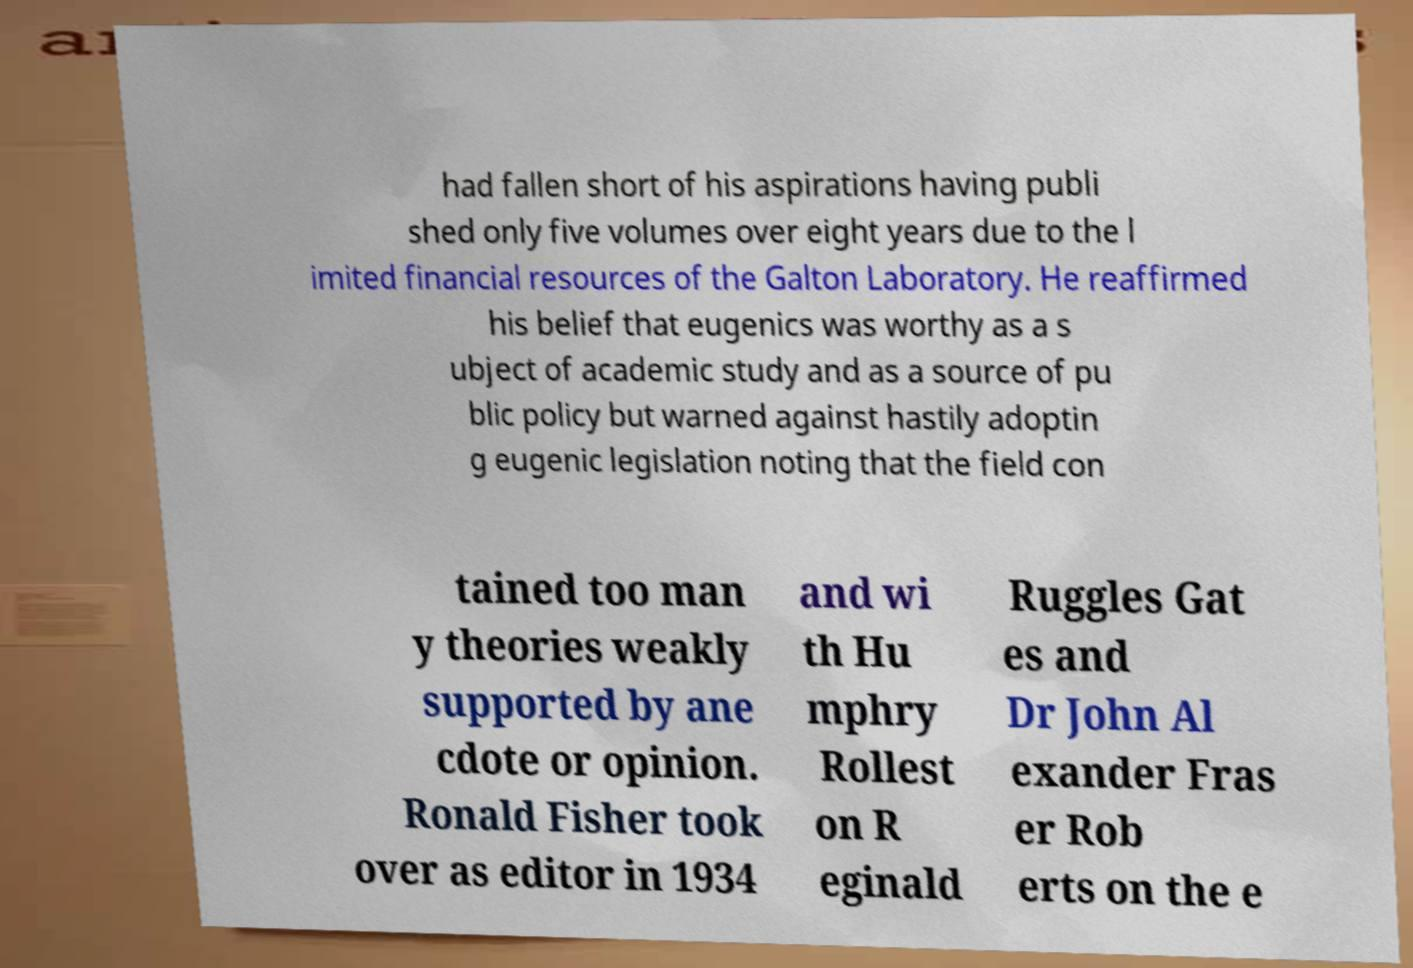Could you extract and type out the text from this image? had fallen short of his aspirations having publi shed only five volumes over eight years due to the l imited financial resources of the Galton Laboratory. He reaffirmed his belief that eugenics was worthy as a s ubject of academic study and as a source of pu blic policy but warned against hastily adoptin g eugenic legislation noting that the field con tained too man y theories weakly supported by ane cdote or opinion. Ronald Fisher took over as editor in 1934 and wi th Hu mphry Rollest on R eginald Ruggles Gat es and Dr John Al exander Fras er Rob erts on the e 